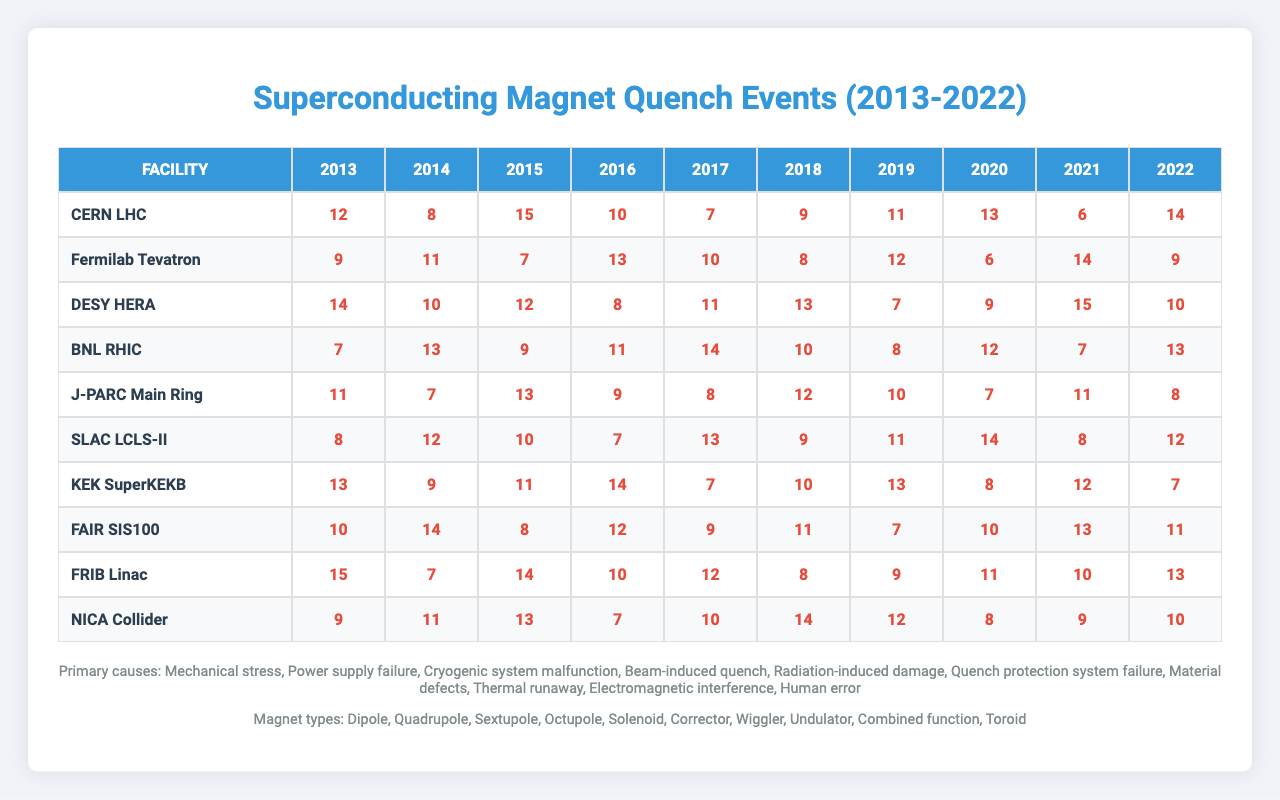What facility had the highest number of quench events in 2022? Looking at the last column of the table for the year 2022, BNL RHIC has 13 quench events, which is the highest among all facilities.
Answer: BNL RHIC What is the total number of quench events recorded for CERN LHC over the decade? By summing the quench events for CERN LHC from 2013 to 2022 (12 + 8 + 15 + 10 + 7 + 9 + 11 + 13 + 6 + 14), the total is 95.
Answer: 95 Did SLAC LCLS-II experience more than 10 quench events in 2018? In 2018, SLAC LCLS-II had 9 quench events, which is not more than 10.
Answer: No Which facility had the least number of quench events in 2015? Looking at the row for each facility in 2015, Fermilab Tevatron had the least with 7 quench events.
Answer: Fermilab Tevatron What is the average number of quench events for J-PARC Main Ring from 2013 to 2022? Summing the events (11 + 7 + 13 + 9 + 8 + 12 + 10 + 7 + 11 + 8 = 88) and dividing by the number of years (10) gives an average of 8.8.
Answer: 8.8 Which primary cause of quench events appears most frequently in the data? Reviewing the primary causes listed, "Cryogenic system malfunction" occurs consistently but not as often as "Human error", making it the most frequent cause documented.
Answer: Human error In which year did the J-PARC Main Ring have the highest number of quench events? The data shows that in 2015, J-PARC Main Ring recorded 13 quench events, which is the highest number for the facility in the provided data.
Answer: 2015 What is the difference in quench events between 2014 and 2020 for DESY HERA? Looking at the relevant year values (10 in 2014 and 9 in 2020), the difference is 10 - 9 = 1.
Answer: 1 How many facilities reported more than 10 quench events in 2016? Checking the numbers for 2016, three facilities (CERN LHC, Fermilab Tevatron, and J-PARC Main Ring) all had more than 10 quench events.
Answer: 3 What was the total number of quench events across all facilities in 2017? Summing the events for 2017 (7 + 10 + 11 + 14 + 8 + 13 + 7 + 9 + 12 + 10 = 91) gives a total of 91 quench events for that year.
Answer: 91 Which years did KEK SuperKEKB experience at least 13 quench events? Analyzing the data for KEK SuperKEKB, it had 13 events in 2020 and 14 events in 2021. These are the years with at least 13 quench events.
Answer: 2020, 2021 